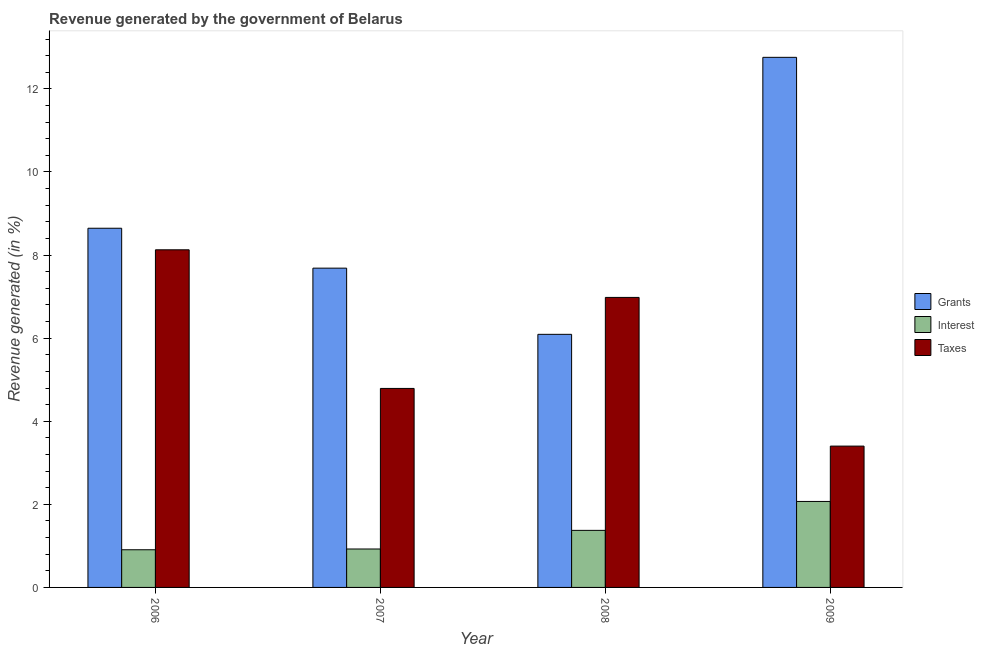How many groups of bars are there?
Your answer should be very brief. 4. Are the number of bars per tick equal to the number of legend labels?
Provide a short and direct response. Yes. How many bars are there on the 4th tick from the left?
Offer a terse response. 3. How many bars are there on the 3rd tick from the right?
Ensure brevity in your answer.  3. What is the label of the 4th group of bars from the left?
Give a very brief answer. 2009. What is the percentage of revenue generated by interest in 2007?
Your answer should be compact. 0.93. Across all years, what is the maximum percentage of revenue generated by interest?
Provide a succinct answer. 2.07. Across all years, what is the minimum percentage of revenue generated by grants?
Give a very brief answer. 6.09. What is the total percentage of revenue generated by grants in the graph?
Provide a succinct answer. 35.18. What is the difference between the percentage of revenue generated by interest in 2006 and that in 2008?
Your response must be concise. -0.47. What is the difference between the percentage of revenue generated by taxes in 2008 and the percentage of revenue generated by interest in 2009?
Keep it short and to the point. 3.58. What is the average percentage of revenue generated by grants per year?
Your answer should be compact. 8.8. In the year 2009, what is the difference between the percentage of revenue generated by taxes and percentage of revenue generated by grants?
Keep it short and to the point. 0. What is the ratio of the percentage of revenue generated by grants in 2006 to that in 2008?
Your answer should be very brief. 1.42. What is the difference between the highest and the second highest percentage of revenue generated by interest?
Keep it short and to the point. 0.7. What is the difference between the highest and the lowest percentage of revenue generated by taxes?
Make the answer very short. 4.72. What does the 1st bar from the left in 2009 represents?
Give a very brief answer. Grants. What does the 1st bar from the right in 2007 represents?
Ensure brevity in your answer.  Taxes. Is it the case that in every year, the sum of the percentage of revenue generated by grants and percentage of revenue generated by interest is greater than the percentage of revenue generated by taxes?
Your answer should be compact. Yes. Are all the bars in the graph horizontal?
Give a very brief answer. No. How many years are there in the graph?
Offer a terse response. 4. Are the values on the major ticks of Y-axis written in scientific E-notation?
Keep it short and to the point. No. Does the graph contain any zero values?
Provide a succinct answer. No. Does the graph contain grids?
Offer a terse response. No. Where does the legend appear in the graph?
Give a very brief answer. Center right. How many legend labels are there?
Make the answer very short. 3. What is the title of the graph?
Provide a succinct answer. Revenue generated by the government of Belarus. Does "Other sectors" appear as one of the legend labels in the graph?
Give a very brief answer. No. What is the label or title of the Y-axis?
Your answer should be very brief. Revenue generated (in %). What is the Revenue generated (in %) in Grants in 2006?
Make the answer very short. 8.65. What is the Revenue generated (in %) of Interest in 2006?
Offer a very short reply. 0.91. What is the Revenue generated (in %) of Taxes in 2006?
Your answer should be very brief. 8.13. What is the Revenue generated (in %) in Grants in 2007?
Provide a short and direct response. 7.68. What is the Revenue generated (in %) of Interest in 2007?
Make the answer very short. 0.93. What is the Revenue generated (in %) in Taxes in 2007?
Your answer should be very brief. 4.79. What is the Revenue generated (in %) in Grants in 2008?
Provide a succinct answer. 6.09. What is the Revenue generated (in %) in Interest in 2008?
Offer a very short reply. 1.37. What is the Revenue generated (in %) in Taxes in 2008?
Offer a terse response. 6.98. What is the Revenue generated (in %) of Grants in 2009?
Provide a succinct answer. 12.76. What is the Revenue generated (in %) of Interest in 2009?
Your response must be concise. 2.07. What is the Revenue generated (in %) in Taxes in 2009?
Your answer should be compact. 3.4. Across all years, what is the maximum Revenue generated (in %) of Grants?
Offer a very short reply. 12.76. Across all years, what is the maximum Revenue generated (in %) in Interest?
Ensure brevity in your answer.  2.07. Across all years, what is the maximum Revenue generated (in %) of Taxes?
Give a very brief answer. 8.13. Across all years, what is the minimum Revenue generated (in %) of Grants?
Your response must be concise. 6.09. Across all years, what is the minimum Revenue generated (in %) in Interest?
Give a very brief answer. 0.91. Across all years, what is the minimum Revenue generated (in %) of Taxes?
Ensure brevity in your answer.  3.4. What is the total Revenue generated (in %) of Grants in the graph?
Keep it short and to the point. 35.18. What is the total Revenue generated (in %) of Interest in the graph?
Your response must be concise. 5.27. What is the total Revenue generated (in %) in Taxes in the graph?
Ensure brevity in your answer.  23.3. What is the difference between the Revenue generated (in %) of Grants in 2006 and that in 2007?
Offer a very short reply. 0.96. What is the difference between the Revenue generated (in %) of Interest in 2006 and that in 2007?
Your answer should be compact. -0.02. What is the difference between the Revenue generated (in %) of Taxes in 2006 and that in 2007?
Your answer should be very brief. 3.34. What is the difference between the Revenue generated (in %) of Grants in 2006 and that in 2008?
Give a very brief answer. 2.55. What is the difference between the Revenue generated (in %) of Interest in 2006 and that in 2008?
Keep it short and to the point. -0.47. What is the difference between the Revenue generated (in %) of Taxes in 2006 and that in 2008?
Make the answer very short. 1.15. What is the difference between the Revenue generated (in %) of Grants in 2006 and that in 2009?
Make the answer very short. -4.11. What is the difference between the Revenue generated (in %) in Interest in 2006 and that in 2009?
Your answer should be compact. -1.16. What is the difference between the Revenue generated (in %) of Taxes in 2006 and that in 2009?
Offer a very short reply. 4.72. What is the difference between the Revenue generated (in %) in Grants in 2007 and that in 2008?
Give a very brief answer. 1.59. What is the difference between the Revenue generated (in %) of Interest in 2007 and that in 2008?
Give a very brief answer. -0.45. What is the difference between the Revenue generated (in %) in Taxes in 2007 and that in 2008?
Provide a short and direct response. -2.19. What is the difference between the Revenue generated (in %) of Grants in 2007 and that in 2009?
Offer a very short reply. -5.07. What is the difference between the Revenue generated (in %) of Interest in 2007 and that in 2009?
Offer a terse response. -1.14. What is the difference between the Revenue generated (in %) in Taxes in 2007 and that in 2009?
Give a very brief answer. 1.39. What is the difference between the Revenue generated (in %) in Grants in 2008 and that in 2009?
Keep it short and to the point. -6.67. What is the difference between the Revenue generated (in %) in Interest in 2008 and that in 2009?
Ensure brevity in your answer.  -0.7. What is the difference between the Revenue generated (in %) in Taxes in 2008 and that in 2009?
Give a very brief answer. 3.58. What is the difference between the Revenue generated (in %) of Grants in 2006 and the Revenue generated (in %) of Interest in 2007?
Your response must be concise. 7.72. What is the difference between the Revenue generated (in %) in Grants in 2006 and the Revenue generated (in %) in Taxes in 2007?
Your answer should be compact. 3.86. What is the difference between the Revenue generated (in %) of Interest in 2006 and the Revenue generated (in %) of Taxes in 2007?
Provide a short and direct response. -3.88. What is the difference between the Revenue generated (in %) in Grants in 2006 and the Revenue generated (in %) in Interest in 2008?
Provide a short and direct response. 7.27. What is the difference between the Revenue generated (in %) in Grants in 2006 and the Revenue generated (in %) in Taxes in 2008?
Your answer should be very brief. 1.66. What is the difference between the Revenue generated (in %) of Interest in 2006 and the Revenue generated (in %) of Taxes in 2008?
Offer a very short reply. -6.07. What is the difference between the Revenue generated (in %) of Grants in 2006 and the Revenue generated (in %) of Interest in 2009?
Ensure brevity in your answer.  6.58. What is the difference between the Revenue generated (in %) of Grants in 2006 and the Revenue generated (in %) of Taxes in 2009?
Make the answer very short. 5.24. What is the difference between the Revenue generated (in %) in Interest in 2006 and the Revenue generated (in %) in Taxes in 2009?
Provide a succinct answer. -2.49. What is the difference between the Revenue generated (in %) in Grants in 2007 and the Revenue generated (in %) in Interest in 2008?
Your answer should be compact. 6.31. What is the difference between the Revenue generated (in %) of Grants in 2007 and the Revenue generated (in %) of Taxes in 2008?
Offer a terse response. 0.7. What is the difference between the Revenue generated (in %) of Interest in 2007 and the Revenue generated (in %) of Taxes in 2008?
Give a very brief answer. -6.06. What is the difference between the Revenue generated (in %) in Grants in 2007 and the Revenue generated (in %) in Interest in 2009?
Make the answer very short. 5.62. What is the difference between the Revenue generated (in %) in Grants in 2007 and the Revenue generated (in %) in Taxes in 2009?
Your response must be concise. 4.28. What is the difference between the Revenue generated (in %) in Interest in 2007 and the Revenue generated (in %) in Taxes in 2009?
Provide a short and direct response. -2.48. What is the difference between the Revenue generated (in %) in Grants in 2008 and the Revenue generated (in %) in Interest in 2009?
Keep it short and to the point. 4.02. What is the difference between the Revenue generated (in %) of Grants in 2008 and the Revenue generated (in %) of Taxes in 2009?
Keep it short and to the point. 2.69. What is the difference between the Revenue generated (in %) of Interest in 2008 and the Revenue generated (in %) of Taxes in 2009?
Keep it short and to the point. -2.03. What is the average Revenue generated (in %) of Grants per year?
Make the answer very short. 8.8. What is the average Revenue generated (in %) of Interest per year?
Provide a succinct answer. 1.32. What is the average Revenue generated (in %) of Taxes per year?
Provide a succinct answer. 5.82. In the year 2006, what is the difference between the Revenue generated (in %) in Grants and Revenue generated (in %) in Interest?
Keep it short and to the point. 7.74. In the year 2006, what is the difference between the Revenue generated (in %) in Grants and Revenue generated (in %) in Taxes?
Ensure brevity in your answer.  0.52. In the year 2006, what is the difference between the Revenue generated (in %) in Interest and Revenue generated (in %) in Taxes?
Provide a succinct answer. -7.22. In the year 2007, what is the difference between the Revenue generated (in %) of Grants and Revenue generated (in %) of Interest?
Provide a succinct answer. 6.76. In the year 2007, what is the difference between the Revenue generated (in %) in Grants and Revenue generated (in %) in Taxes?
Your answer should be compact. 2.9. In the year 2007, what is the difference between the Revenue generated (in %) in Interest and Revenue generated (in %) in Taxes?
Provide a short and direct response. -3.86. In the year 2008, what is the difference between the Revenue generated (in %) in Grants and Revenue generated (in %) in Interest?
Offer a terse response. 4.72. In the year 2008, what is the difference between the Revenue generated (in %) in Grants and Revenue generated (in %) in Taxes?
Offer a very short reply. -0.89. In the year 2008, what is the difference between the Revenue generated (in %) of Interest and Revenue generated (in %) of Taxes?
Make the answer very short. -5.61. In the year 2009, what is the difference between the Revenue generated (in %) of Grants and Revenue generated (in %) of Interest?
Keep it short and to the point. 10.69. In the year 2009, what is the difference between the Revenue generated (in %) in Grants and Revenue generated (in %) in Taxes?
Offer a very short reply. 9.36. In the year 2009, what is the difference between the Revenue generated (in %) of Interest and Revenue generated (in %) of Taxes?
Offer a very short reply. -1.33. What is the ratio of the Revenue generated (in %) of Grants in 2006 to that in 2007?
Ensure brevity in your answer.  1.12. What is the ratio of the Revenue generated (in %) of Interest in 2006 to that in 2007?
Make the answer very short. 0.98. What is the ratio of the Revenue generated (in %) in Taxes in 2006 to that in 2007?
Keep it short and to the point. 1.7. What is the ratio of the Revenue generated (in %) in Grants in 2006 to that in 2008?
Keep it short and to the point. 1.42. What is the ratio of the Revenue generated (in %) of Interest in 2006 to that in 2008?
Offer a very short reply. 0.66. What is the ratio of the Revenue generated (in %) in Taxes in 2006 to that in 2008?
Provide a short and direct response. 1.16. What is the ratio of the Revenue generated (in %) in Grants in 2006 to that in 2009?
Ensure brevity in your answer.  0.68. What is the ratio of the Revenue generated (in %) of Interest in 2006 to that in 2009?
Your response must be concise. 0.44. What is the ratio of the Revenue generated (in %) in Taxes in 2006 to that in 2009?
Provide a succinct answer. 2.39. What is the ratio of the Revenue generated (in %) in Grants in 2007 to that in 2008?
Your answer should be very brief. 1.26. What is the ratio of the Revenue generated (in %) in Interest in 2007 to that in 2008?
Give a very brief answer. 0.67. What is the ratio of the Revenue generated (in %) in Taxes in 2007 to that in 2008?
Provide a short and direct response. 0.69. What is the ratio of the Revenue generated (in %) in Grants in 2007 to that in 2009?
Provide a short and direct response. 0.6. What is the ratio of the Revenue generated (in %) in Interest in 2007 to that in 2009?
Your answer should be very brief. 0.45. What is the ratio of the Revenue generated (in %) of Taxes in 2007 to that in 2009?
Provide a succinct answer. 1.41. What is the ratio of the Revenue generated (in %) in Grants in 2008 to that in 2009?
Provide a short and direct response. 0.48. What is the ratio of the Revenue generated (in %) of Interest in 2008 to that in 2009?
Your response must be concise. 0.66. What is the ratio of the Revenue generated (in %) of Taxes in 2008 to that in 2009?
Offer a very short reply. 2.05. What is the difference between the highest and the second highest Revenue generated (in %) of Grants?
Ensure brevity in your answer.  4.11. What is the difference between the highest and the second highest Revenue generated (in %) of Interest?
Offer a very short reply. 0.7. What is the difference between the highest and the second highest Revenue generated (in %) of Taxes?
Give a very brief answer. 1.15. What is the difference between the highest and the lowest Revenue generated (in %) of Grants?
Offer a terse response. 6.67. What is the difference between the highest and the lowest Revenue generated (in %) in Interest?
Ensure brevity in your answer.  1.16. What is the difference between the highest and the lowest Revenue generated (in %) in Taxes?
Offer a terse response. 4.72. 